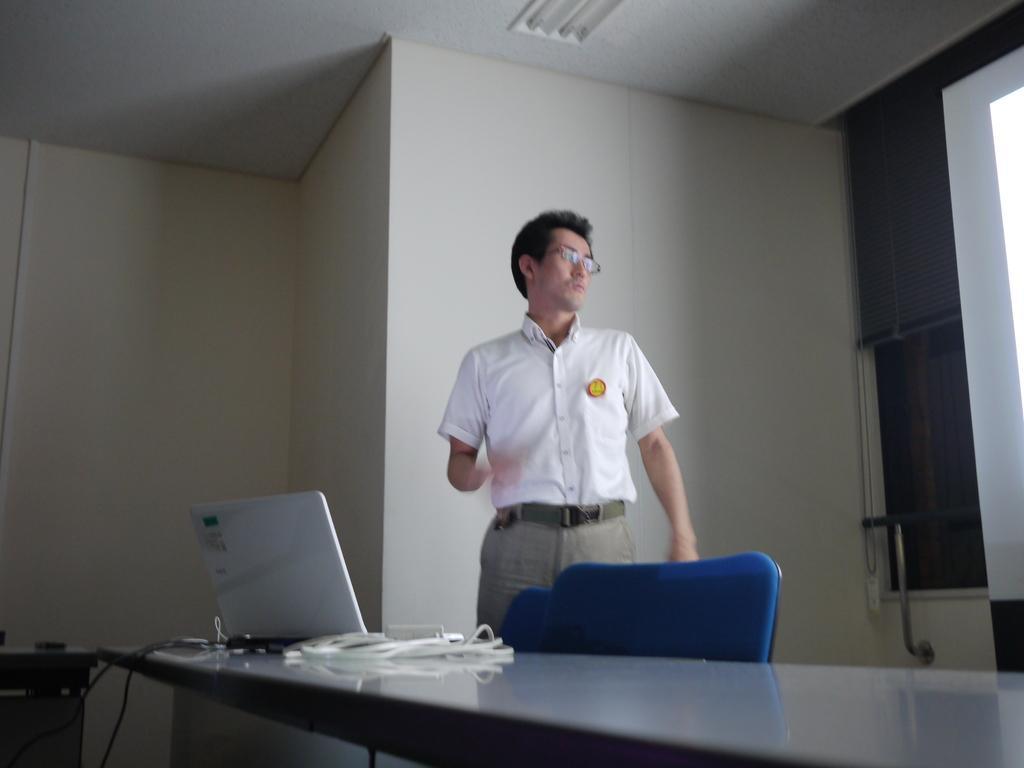Please provide a concise description of this image. This picture is of inside. In the center there is a table on the top of which a Laptop and a cable is placed, behind that there are two chairs and a man wearing a white color shirt and standing. In the background there is a wall and a window with a window blind. 